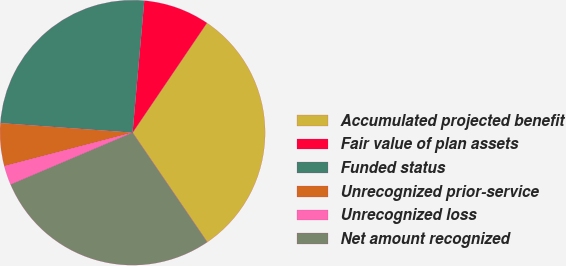Convert chart. <chart><loc_0><loc_0><loc_500><loc_500><pie_chart><fcel>Accumulated projected benefit<fcel>Fair value of plan assets<fcel>Funded status<fcel>Unrecognized prior-service<fcel>Unrecognized loss<fcel>Net amount recognized<nl><fcel>30.99%<fcel>8.07%<fcel>25.26%<fcel>5.21%<fcel>2.34%<fcel>28.12%<nl></chart> 